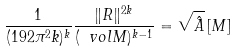<formula> <loc_0><loc_0><loc_500><loc_500>\frac { 1 } { ( 1 9 2 \pi ^ { 2 } k ) ^ { k } } \frac { \| R \| ^ { 2 k } } { ( \ v o l M ) ^ { k - 1 } } = \sqrt { \hat { A } } \, [ M ]</formula> 